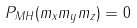<formula> <loc_0><loc_0><loc_500><loc_500>P _ { M H } ( m _ { x } m _ { y } m _ { z } ) = 0</formula> 